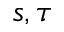Convert formula to latex. <formula><loc_0><loc_0><loc_500><loc_500>s , \tau</formula> 